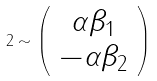Convert formula to latex. <formula><loc_0><loc_0><loc_500><loc_500>2 \sim \left ( \begin{array} { c } \alpha \beta _ { 1 } \\ - \alpha \beta _ { 2 } \end{array} \right )</formula> 